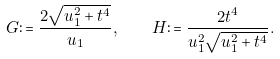Convert formula to latex. <formula><loc_0><loc_0><loc_500><loc_500>G \colon = \frac { 2 \sqrt { u _ { 1 } ^ { 2 } + t ^ { 4 } } } { u _ { 1 } } , \quad H \colon = \frac { 2 t ^ { 4 } } { u _ { 1 } ^ { 2 } \sqrt { u _ { 1 } ^ { 2 } + t ^ { 4 } } } .</formula> 